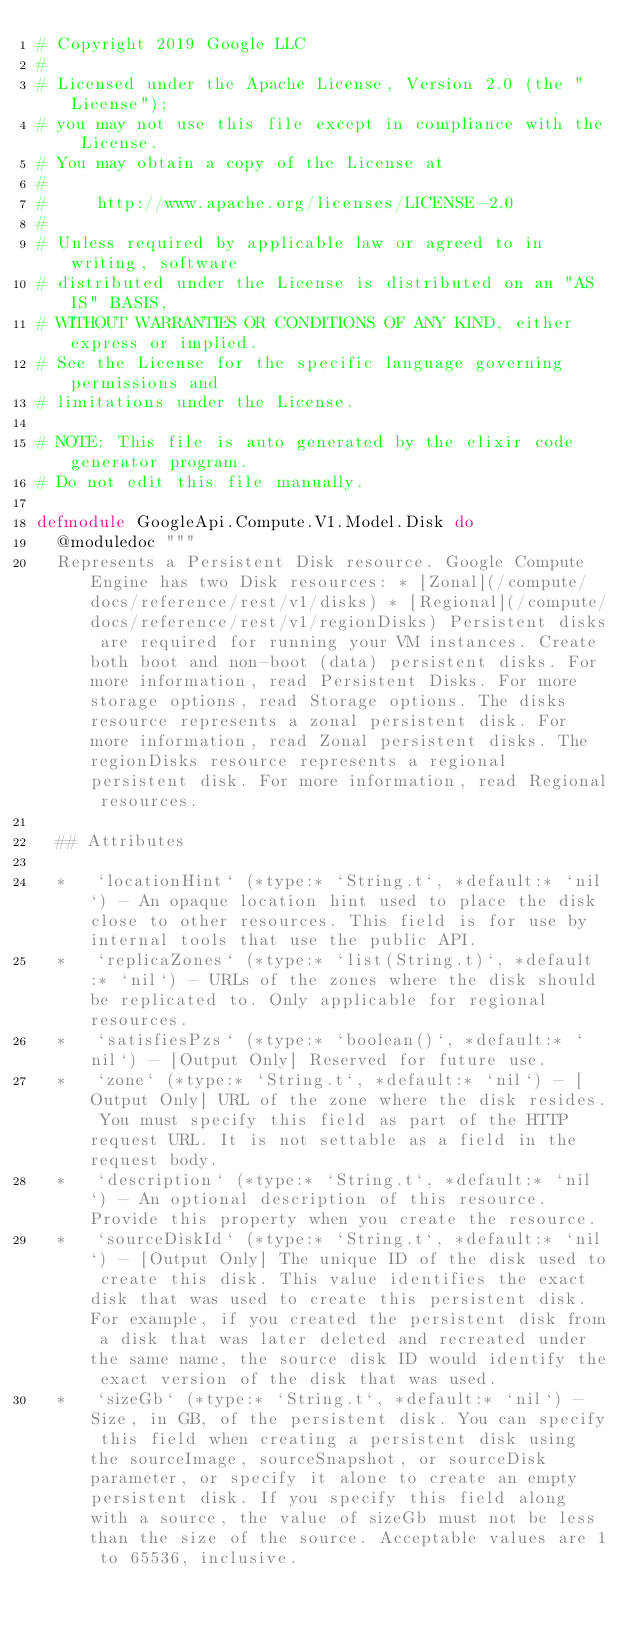<code> <loc_0><loc_0><loc_500><loc_500><_Elixir_># Copyright 2019 Google LLC
#
# Licensed under the Apache License, Version 2.0 (the "License");
# you may not use this file except in compliance with the License.
# You may obtain a copy of the License at
#
#     http://www.apache.org/licenses/LICENSE-2.0
#
# Unless required by applicable law or agreed to in writing, software
# distributed under the License is distributed on an "AS IS" BASIS,
# WITHOUT WARRANTIES OR CONDITIONS OF ANY KIND, either express or implied.
# See the License for the specific language governing permissions and
# limitations under the License.

# NOTE: This file is auto generated by the elixir code generator program.
# Do not edit this file manually.

defmodule GoogleApi.Compute.V1.Model.Disk do
  @moduledoc """
  Represents a Persistent Disk resource. Google Compute Engine has two Disk resources: * [Zonal](/compute/docs/reference/rest/v1/disks) * [Regional](/compute/docs/reference/rest/v1/regionDisks) Persistent disks are required for running your VM instances. Create both boot and non-boot (data) persistent disks. For more information, read Persistent Disks. For more storage options, read Storage options. The disks resource represents a zonal persistent disk. For more information, read Zonal persistent disks. The regionDisks resource represents a regional persistent disk. For more information, read Regional resources.

  ## Attributes

  *   `locationHint` (*type:* `String.t`, *default:* `nil`) - An opaque location hint used to place the disk close to other resources. This field is for use by internal tools that use the public API.
  *   `replicaZones` (*type:* `list(String.t)`, *default:* `nil`) - URLs of the zones where the disk should be replicated to. Only applicable for regional resources.
  *   `satisfiesPzs` (*type:* `boolean()`, *default:* `nil`) - [Output Only] Reserved for future use.
  *   `zone` (*type:* `String.t`, *default:* `nil`) - [Output Only] URL of the zone where the disk resides. You must specify this field as part of the HTTP request URL. It is not settable as a field in the request body.
  *   `description` (*type:* `String.t`, *default:* `nil`) - An optional description of this resource. Provide this property when you create the resource.
  *   `sourceDiskId` (*type:* `String.t`, *default:* `nil`) - [Output Only] The unique ID of the disk used to create this disk. This value identifies the exact disk that was used to create this persistent disk. For example, if you created the persistent disk from a disk that was later deleted and recreated under the same name, the source disk ID would identify the exact version of the disk that was used.
  *   `sizeGb` (*type:* `String.t`, *default:* `nil`) - Size, in GB, of the persistent disk. You can specify this field when creating a persistent disk using the sourceImage, sourceSnapshot, or sourceDisk parameter, or specify it alone to create an empty persistent disk. If you specify this field along with a source, the value of sizeGb must not be less than the size of the source. Acceptable values are 1 to 65536, inclusive.</code> 